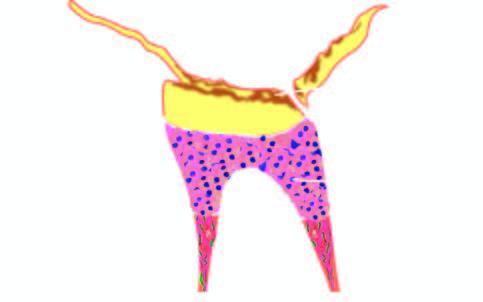what is there of enamel, deposition of secondary dentine and evidence of pulpitis?
Answer the question using a single word or phrase. Complete destruction 